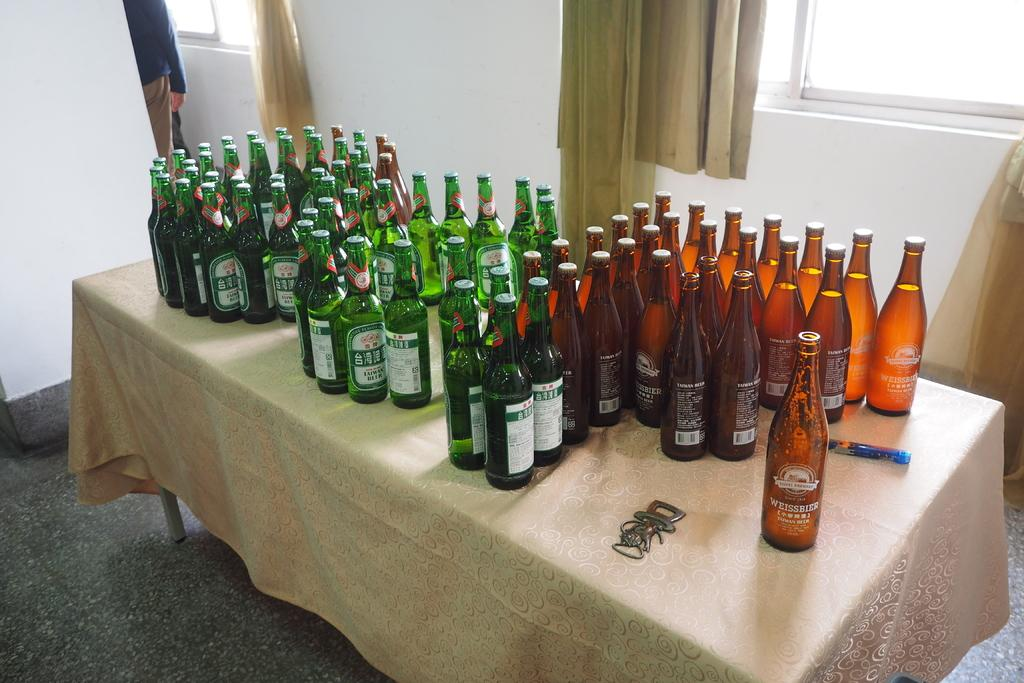Provide a one-sentence caption for the provided image. A table is covered with Taiwan beer bottles. 